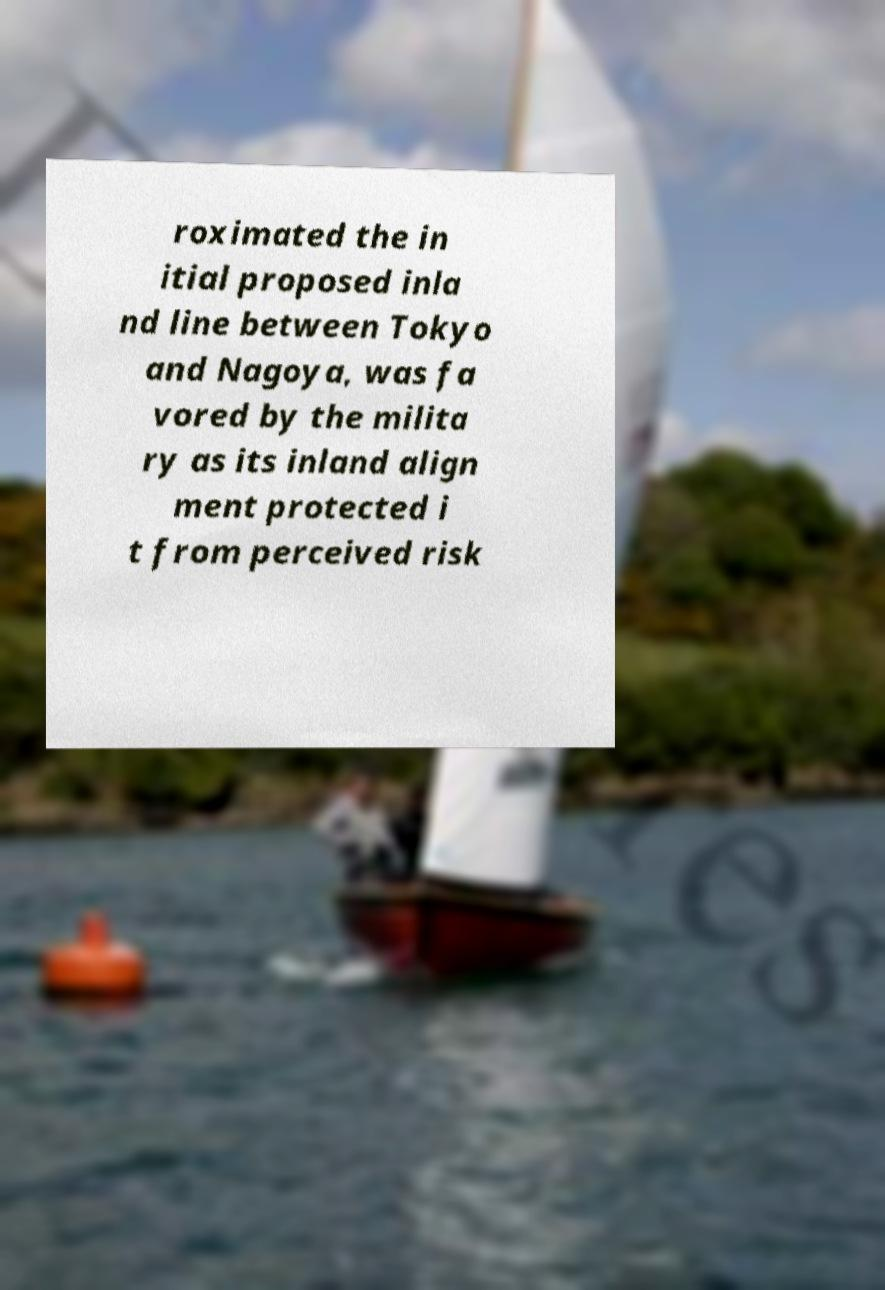There's text embedded in this image that I need extracted. Can you transcribe it verbatim? roximated the in itial proposed inla nd line between Tokyo and Nagoya, was fa vored by the milita ry as its inland align ment protected i t from perceived risk 